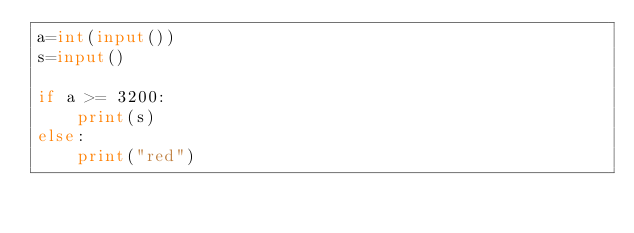Convert code to text. <code><loc_0><loc_0><loc_500><loc_500><_Python_>a=int(input())
s=input()

if a >= 3200:
    print(s)
else:
    print("red")</code> 